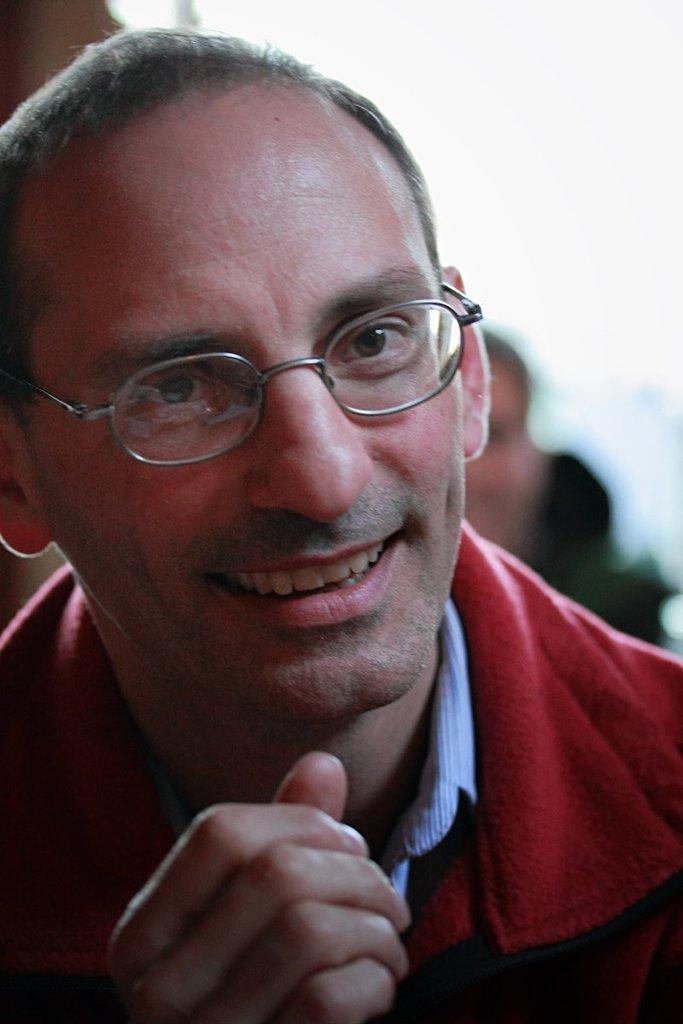Who is present in the image? There is a man in the image. What is the man wearing in the image? The man is wearing spectacles in the image. Can you describe the background of the image? There is a person visible in the background of the image. What type of bomb is the man holding in the image? There is no bomb present in the image; the man is wearing spectacles and there is another person visible in the background. 